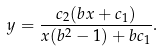<formula> <loc_0><loc_0><loc_500><loc_500>y = \frac { c _ { 2 } ( b x + c _ { 1 } ) } { x ( b ^ { 2 } - 1 ) + b c _ { 1 } } .</formula> 